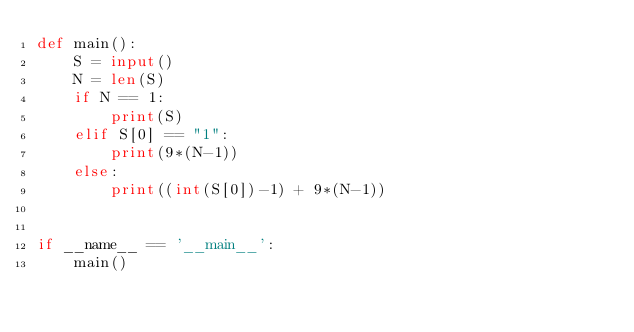Convert code to text. <code><loc_0><loc_0><loc_500><loc_500><_Python_>def main():
    S = input()
    N = len(S)
    if N == 1:
        print(S)
    elif S[0] == "1":
        print(9*(N-1))
    else:
        print((int(S[0])-1) + 9*(N-1))


if __name__ == '__main__':
    main()
</code> 